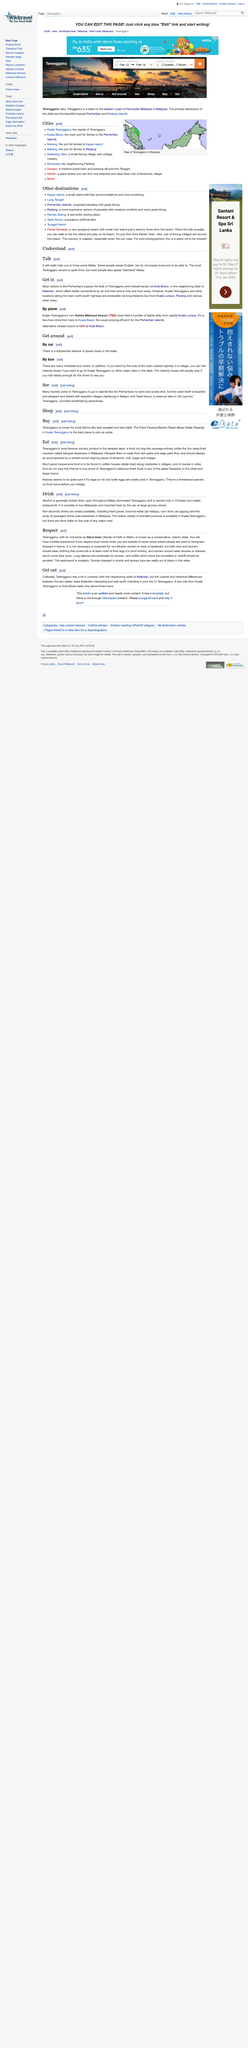Indicate a few pertinent items in this graphic. Kota Bharu airport is denoted by the three letter abbreviation KBR. The capital city mentioned in the article is Kuala Lumpur. Sultan Mahmud Airport is denoted by the three letter abbreviation TGG. 